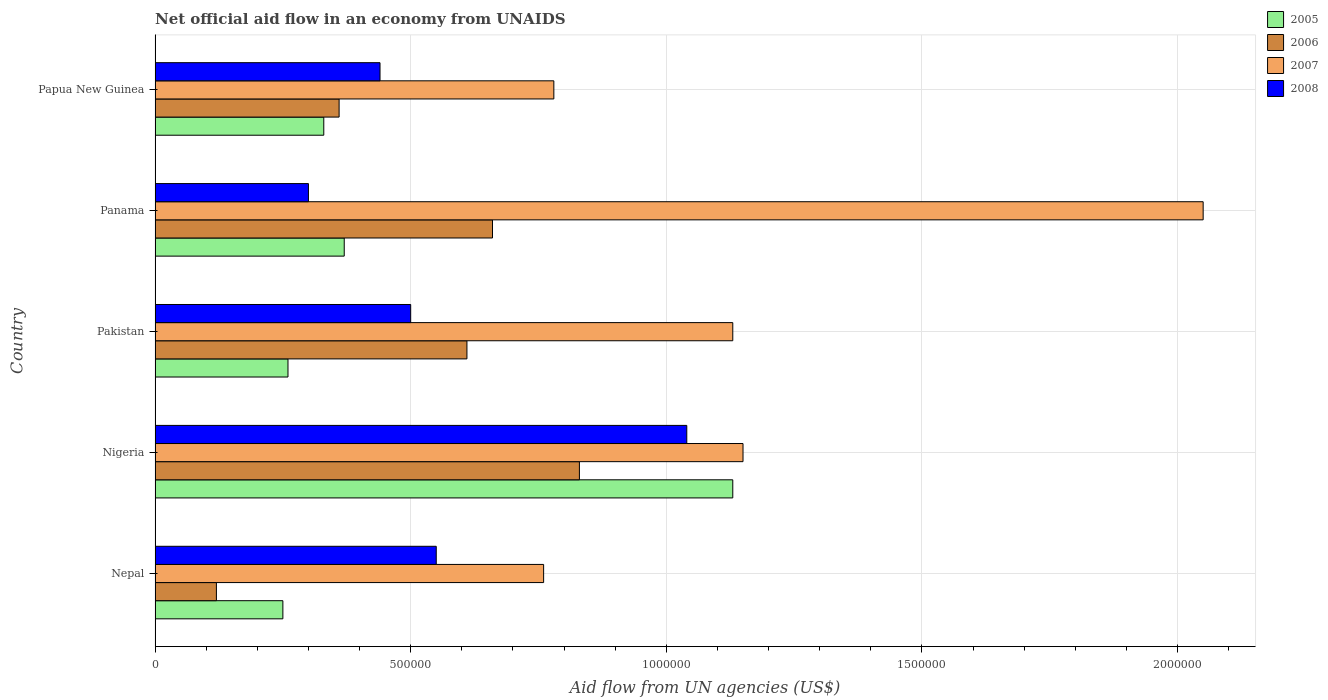How many groups of bars are there?
Offer a terse response. 5. Are the number of bars on each tick of the Y-axis equal?
Offer a very short reply. Yes. What is the label of the 5th group of bars from the top?
Make the answer very short. Nepal. Across all countries, what is the maximum net official aid flow in 2007?
Provide a succinct answer. 2.05e+06. Across all countries, what is the minimum net official aid flow in 2008?
Give a very brief answer. 3.00e+05. In which country was the net official aid flow in 2007 maximum?
Keep it short and to the point. Panama. In which country was the net official aid flow in 2006 minimum?
Keep it short and to the point. Nepal. What is the total net official aid flow in 2005 in the graph?
Your answer should be very brief. 2.34e+06. What is the difference between the net official aid flow in 2008 in Nigeria and that in Panama?
Ensure brevity in your answer.  7.40e+05. What is the difference between the net official aid flow in 2007 in Panama and the net official aid flow in 2005 in Pakistan?
Provide a succinct answer. 1.79e+06. What is the average net official aid flow in 2008 per country?
Your response must be concise. 5.66e+05. What is the difference between the net official aid flow in 2007 and net official aid flow in 2006 in Nepal?
Your answer should be compact. 6.40e+05. What is the ratio of the net official aid flow in 2006 in Nepal to that in Pakistan?
Provide a succinct answer. 0.2. Is the difference between the net official aid flow in 2007 in Panama and Papua New Guinea greater than the difference between the net official aid flow in 2006 in Panama and Papua New Guinea?
Offer a terse response. Yes. What is the difference between the highest and the second highest net official aid flow in 2005?
Your response must be concise. 7.60e+05. What is the difference between the highest and the lowest net official aid flow in 2005?
Provide a succinct answer. 8.80e+05. Is the sum of the net official aid flow in 2007 in Nigeria and Pakistan greater than the maximum net official aid flow in 2005 across all countries?
Give a very brief answer. Yes. Is it the case that in every country, the sum of the net official aid flow in 2006 and net official aid flow in 2005 is greater than the sum of net official aid flow in 2008 and net official aid flow in 2007?
Your answer should be very brief. No. What does the 3rd bar from the bottom in Papua New Guinea represents?
Ensure brevity in your answer.  2007. How many bars are there?
Give a very brief answer. 20. Are all the bars in the graph horizontal?
Offer a terse response. Yes. How many countries are there in the graph?
Provide a short and direct response. 5. Does the graph contain any zero values?
Give a very brief answer. No. Where does the legend appear in the graph?
Provide a succinct answer. Top right. How many legend labels are there?
Your answer should be compact. 4. What is the title of the graph?
Keep it short and to the point. Net official aid flow in an economy from UNAIDS. What is the label or title of the X-axis?
Your answer should be compact. Aid flow from UN agencies (US$). What is the label or title of the Y-axis?
Your answer should be compact. Country. What is the Aid flow from UN agencies (US$) of 2007 in Nepal?
Offer a terse response. 7.60e+05. What is the Aid flow from UN agencies (US$) of 2005 in Nigeria?
Offer a terse response. 1.13e+06. What is the Aid flow from UN agencies (US$) in 2006 in Nigeria?
Your answer should be compact. 8.30e+05. What is the Aid flow from UN agencies (US$) of 2007 in Nigeria?
Provide a succinct answer. 1.15e+06. What is the Aid flow from UN agencies (US$) in 2008 in Nigeria?
Give a very brief answer. 1.04e+06. What is the Aid flow from UN agencies (US$) of 2006 in Pakistan?
Provide a short and direct response. 6.10e+05. What is the Aid flow from UN agencies (US$) of 2007 in Pakistan?
Ensure brevity in your answer.  1.13e+06. What is the Aid flow from UN agencies (US$) of 2008 in Pakistan?
Offer a terse response. 5.00e+05. What is the Aid flow from UN agencies (US$) in 2005 in Panama?
Offer a very short reply. 3.70e+05. What is the Aid flow from UN agencies (US$) in 2007 in Panama?
Provide a short and direct response. 2.05e+06. What is the Aid flow from UN agencies (US$) of 2005 in Papua New Guinea?
Your response must be concise. 3.30e+05. What is the Aid flow from UN agencies (US$) in 2006 in Papua New Guinea?
Your response must be concise. 3.60e+05. What is the Aid flow from UN agencies (US$) of 2007 in Papua New Guinea?
Keep it short and to the point. 7.80e+05. Across all countries, what is the maximum Aid flow from UN agencies (US$) in 2005?
Ensure brevity in your answer.  1.13e+06. Across all countries, what is the maximum Aid flow from UN agencies (US$) of 2006?
Offer a terse response. 8.30e+05. Across all countries, what is the maximum Aid flow from UN agencies (US$) in 2007?
Your answer should be compact. 2.05e+06. Across all countries, what is the maximum Aid flow from UN agencies (US$) in 2008?
Make the answer very short. 1.04e+06. Across all countries, what is the minimum Aid flow from UN agencies (US$) of 2006?
Your answer should be compact. 1.20e+05. Across all countries, what is the minimum Aid flow from UN agencies (US$) in 2007?
Offer a terse response. 7.60e+05. What is the total Aid flow from UN agencies (US$) in 2005 in the graph?
Your answer should be very brief. 2.34e+06. What is the total Aid flow from UN agencies (US$) of 2006 in the graph?
Your answer should be compact. 2.58e+06. What is the total Aid flow from UN agencies (US$) in 2007 in the graph?
Provide a short and direct response. 5.87e+06. What is the total Aid flow from UN agencies (US$) in 2008 in the graph?
Offer a very short reply. 2.83e+06. What is the difference between the Aid flow from UN agencies (US$) in 2005 in Nepal and that in Nigeria?
Ensure brevity in your answer.  -8.80e+05. What is the difference between the Aid flow from UN agencies (US$) in 2006 in Nepal and that in Nigeria?
Offer a terse response. -7.10e+05. What is the difference between the Aid flow from UN agencies (US$) of 2007 in Nepal and that in Nigeria?
Offer a very short reply. -3.90e+05. What is the difference between the Aid flow from UN agencies (US$) of 2008 in Nepal and that in Nigeria?
Keep it short and to the point. -4.90e+05. What is the difference between the Aid flow from UN agencies (US$) of 2005 in Nepal and that in Pakistan?
Give a very brief answer. -10000. What is the difference between the Aid flow from UN agencies (US$) of 2006 in Nepal and that in Pakistan?
Provide a succinct answer. -4.90e+05. What is the difference between the Aid flow from UN agencies (US$) in 2007 in Nepal and that in Pakistan?
Provide a short and direct response. -3.70e+05. What is the difference between the Aid flow from UN agencies (US$) in 2008 in Nepal and that in Pakistan?
Ensure brevity in your answer.  5.00e+04. What is the difference between the Aid flow from UN agencies (US$) in 2006 in Nepal and that in Panama?
Provide a short and direct response. -5.40e+05. What is the difference between the Aid flow from UN agencies (US$) in 2007 in Nepal and that in Panama?
Keep it short and to the point. -1.29e+06. What is the difference between the Aid flow from UN agencies (US$) of 2008 in Nepal and that in Panama?
Provide a succinct answer. 2.50e+05. What is the difference between the Aid flow from UN agencies (US$) of 2005 in Nepal and that in Papua New Guinea?
Keep it short and to the point. -8.00e+04. What is the difference between the Aid flow from UN agencies (US$) in 2007 in Nepal and that in Papua New Guinea?
Your answer should be compact. -2.00e+04. What is the difference between the Aid flow from UN agencies (US$) of 2008 in Nepal and that in Papua New Guinea?
Ensure brevity in your answer.  1.10e+05. What is the difference between the Aid flow from UN agencies (US$) of 2005 in Nigeria and that in Pakistan?
Ensure brevity in your answer.  8.70e+05. What is the difference between the Aid flow from UN agencies (US$) of 2008 in Nigeria and that in Pakistan?
Provide a short and direct response. 5.40e+05. What is the difference between the Aid flow from UN agencies (US$) of 2005 in Nigeria and that in Panama?
Provide a short and direct response. 7.60e+05. What is the difference between the Aid flow from UN agencies (US$) in 2006 in Nigeria and that in Panama?
Offer a terse response. 1.70e+05. What is the difference between the Aid flow from UN agencies (US$) of 2007 in Nigeria and that in Panama?
Provide a succinct answer. -9.00e+05. What is the difference between the Aid flow from UN agencies (US$) in 2008 in Nigeria and that in Panama?
Keep it short and to the point. 7.40e+05. What is the difference between the Aid flow from UN agencies (US$) of 2005 in Nigeria and that in Papua New Guinea?
Your response must be concise. 8.00e+05. What is the difference between the Aid flow from UN agencies (US$) of 2007 in Nigeria and that in Papua New Guinea?
Make the answer very short. 3.70e+05. What is the difference between the Aid flow from UN agencies (US$) of 2008 in Nigeria and that in Papua New Guinea?
Your answer should be compact. 6.00e+05. What is the difference between the Aid flow from UN agencies (US$) of 2005 in Pakistan and that in Panama?
Provide a short and direct response. -1.10e+05. What is the difference between the Aid flow from UN agencies (US$) in 2007 in Pakistan and that in Panama?
Provide a succinct answer. -9.20e+05. What is the difference between the Aid flow from UN agencies (US$) of 2008 in Pakistan and that in Panama?
Your response must be concise. 2.00e+05. What is the difference between the Aid flow from UN agencies (US$) in 2006 in Pakistan and that in Papua New Guinea?
Ensure brevity in your answer.  2.50e+05. What is the difference between the Aid flow from UN agencies (US$) of 2007 in Panama and that in Papua New Guinea?
Provide a succinct answer. 1.27e+06. What is the difference between the Aid flow from UN agencies (US$) in 2008 in Panama and that in Papua New Guinea?
Your answer should be compact. -1.40e+05. What is the difference between the Aid flow from UN agencies (US$) of 2005 in Nepal and the Aid flow from UN agencies (US$) of 2006 in Nigeria?
Provide a short and direct response. -5.80e+05. What is the difference between the Aid flow from UN agencies (US$) of 2005 in Nepal and the Aid flow from UN agencies (US$) of 2007 in Nigeria?
Your answer should be very brief. -9.00e+05. What is the difference between the Aid flow from UN agencies (US$) of 2005 in Nepal and the Aid flow from UN agencies (US$) of 2008 in Nigeria?
Give a very brief answer. -7.90e+05. What is the difference between the Aid flow from UN agencies (US$) of 2006 in Nepal and the Aid flow from UN agencies (US$) of 2007 in Nigeria?
Ensure brevity in your answer.  -1.03e+06. What is the difference between the Aid flow from UN agencies (US$) of 2006 in Nepal and the Aid flow from UN agencies (US$) of 2008 in Nigeria?
Provide a short and direct response. -9.20e+05. What is the difference between the Aid flow from UN agencies (US$) in 2007 in Nepal and the Aid flow from UN agencies (US$) in 2008 in Nigeria?
Your response must be concise. -2.80e+05. What is the difference between the Aid flow from UN agencies (US$) in 2005 in Nepal and the Aid flow from UN agencies (US$) in 2006 in Pakistan?
Provide a succinct answer. -3.60e+05. What is the difference between the Aid flow from UN agencies (US$) of 2005 in Nepal and the Aid flow from UN agencies (US$) of 2007 in Pakistan?
Provide a short and direct response. -8.80e+05. What is the difference between the Aid flow from UN agencies (US$) of 2006 in Nepal and the Aid flow from UN agencies (US$) of 2007 in Pakistan?
Provide a succinct answer. -1.01e+06. What is the difference between the Aid flow from UN agencies (US$) of 2006 in Nepal and the Aid flow from UN agencies (US$) of 2008 in Pakistan?
Provide a succinct answer. -3.80e+05. What is the difference between the Aid flow from UN agencies (US$) in 2005 in Nepal and the Aid flow from UN agencies (US$) in 2006 in Panama?
Your answer should be very brief. -4.10e+05. What is the difference between the Aid flow from UN agencies (US$) of 2005 in Nepal and the Aid flow from UN agencies (US$) of 2007 in Panama?
Offer a terse response. -1.80e+06. What is the difference between the Aid flow from UN agencies (US$) of 2005 in Nepal and the Aid flow from UN agencies (US$) of 2008 in Panama?
Ensure brevity in your answer.  -5.00e+04. What is the difference between the Aid flow from UN agencies (US$) in 2006 in Nepal and the Aid flow from UN agencies (US$) in 2007 in Panama?
Provide a short and direct response. -1.93e+06. What is the difference between the Aid flow from UN agencies (US$) of 2006 in Nepal and the Aid flow from UN agencies (US$) of 2008 in Panama?
Keep it short and to the point. -1.80e+05. What is the difference between the Aid flow from UN agencies (US$) in 2007 in Nepal and the Aid flow from UN agencies (US$) in 2008 in Panama?
Make the answer very short. 4.60e+05. What is the difference between the Aid flow from UN agencies (US$) in 2005 in Nepal and the Aid flow from UN agencies (US$) in 2006 in Papua New Guinea?
Offer a very short reply. -1.10e+05. What is the difference between the Aid flow from UN agencies (US$) of 2005 in Nepal and the Aid flow from UN agencies (US$) of 2007 in Papua New Guinea?
Your answer should be very brief. -5.30e+05. What is the difference between the Aid flow from UN agencies (US$) in 2006 in Nepal and the Aid flow from UN agencies (US$) in 2007 in Papua New Guinea?
Ensure brevity in your answer.  -6.60e+05. What is the difference between the Aid flow from UN agencies (US$) of 2006 in Nepal and the Aid flow from UN agencies (US$) of 2008 in Papua New Guinea?
Provide a succinct answer. -3.20e+05. What is the difference between the Aid flow from UN agencies (US$) in 2005 in Nigeria and the Aid flow from UN agencies (US$) in 2006 in Pakistan?
Make the answer very short. 5.20e+05. What is the difference between the Aid flow from UN agencies (US$) of 2005 in Nigeria and the Aid flow from UN agencies (US$) of 2008 in Pakistan?
Provide a short and direct response. 6.30e+05. What is the difference between the Aid flow from UN agencies (US$) of 2006 in Nigeria and the Aid flow from UN agencies (US$) of 2007 in Pakistan?
Your answer should be very brief. -3.00e+05. What is the difference between the Aid flow from UN agencies (US$) in 2006 in Nigeria and the Aid flow from UN agencies (US$) in 2008 in Pakistan?
Provide a succinct answer. 3.30e+05. What is the difference between the Aid flow from UN agencies (US$) of 2007 in Nigeria and the Aid flow from UN agencies (US$) of 2008 in Pakistan?
Your response must be concise. 6.50e+05. What is the difference between the Aid flow from UN agencies (US$) in 2005 in Nigeria and the Aid flow from UN agencies (US$) in 2006 in Panama?
Give a very brief answer. 4.70e+05. What is the difference between the Aid flow from UN agencies (US$) of 2005 in Nigeria and the Aid flow from UN agencies (US$) of 2007 in Panama?
Ensure brevity in your answer.  -9.20e+05. What is the difference between the Aid flow from UN agencies (US$) of 2005 in Nigeria and the Aid flow from UN agencies (US$) of 2008 in Panama?
Ensure brevity in your answer.  8.30e+05. What is the difference between the Aid flow from UN agencies (US$) in 2006 in Nigeria and the Aid flow from UN agencies (US$) in 2007 in Panama?
Provide a succinct answer. -1.22e+06. What is the difference between the Aid flow from UN agencies (US$) in 2006 in Nigeria and the Aid flow from UN agencies (US$) in 2008 in Panama?
Your answer should be very brief. 5.30e+05. What is the difference between the Aid flow from UN agencies (US$) in 2007 in Nigeria and the Aid flow from UN agencies (US$) in 2008 in Panama?
Offer a terse response. 8.50e+05. What is the difference between the Aid flow from UN agencies (US$) in 2005 in Nigeria and the Aid flow from UN agencies (US$) in 2006 in Papua New Guinea?
Make the answer very short. 7.70e+05. What is the difference between the Aid flow from UN agencies (US$) of 2005 in Nigeria and the Aid flow from UN agencies (US$) of 2007 in Papua New Guinea?
Make the answer very short. 3.50e+05. What is the difference between the Aid flow from UN agencies (US$) of 2005 in Nigeria and the Aid flow from UN agencies (US$) of 2008 in Papua New Guinea?
Keep it short and to the point. 6.90e+05. What is the difference between the Aid flow from UN agencies (US$) in 2006 in Nigeria and the Aid flow from UN agencies (US$) in 2007 in Papua New Guinea?
Provide a short and direct response. 5.00e+04. What is the difference between the Aid flow from UN agencies (US$) in 2007 in Nigeria and the Aid flow from UN agencies (US$) in 2008 in Papua New Guinea?
Your answer should be compact. 7.10e+05. What is the difference between the Aid flow from UN agencies (US$) in 2005 in Pakistan and the Aid flow from UN agencies (US$) in 2006 in Panama?
Provide a short and direct response. -4.00e+05. What is the difference between the Aid flow from UN agencies (US$) in 2005 in Pakistan and the Aid flow from UN agencies (US$) in 2007 in Panama?
Keep it short and to the point. -1.79e+06. What is the difference between the Aid flow from UN agencies (US$) in 2006 in Pakistan and the Aid flow from UN agencies (US$) in 2007 in Panama?
Keep it short and to the point. -1.44e+06. What is the difference between the Aid flow from UN agencies (US$) in 2006 in Pakistan and the Aid flow from UN agencies (US$) in 2008 in Panama?
Your response must be concise. 3.10e+05. What is the difference between the Aid flow from UN agencies (US$) in 2007 in Pakistan and the Aid flow from UN agencies (US$) in 2008 in Panama?
Your response must be concise. 8.30e+05. What is the difference between the Aid flow from UN agencies (US$) in 2005 in Pakistan and the Aid flow from UN agencies (US$) in 2007 in Papua New Guinea?
Offer a terse response. -5.20e+05. What is the difference between the Aid flow from UN agencies (US$) in 2005 in Pakistan and the Aid flow from UN agencies (US$) in 2008 in Papua New Guinea?
Keep it short and to the point. -1.80e+05. What is the difference between the Aid flow from UN agencies (US$) in 2006 in Pakistan and the Aid flow from UN agencies (US$) in 2007 in Papua New Guinea?
Ensure brevity in your answer.  -1.70e+05. What is the difference between the Aid flow from UN agencies (US$) in 2006 in Pakistan and the Aid flow from UN agencies (US$) in 2008 in Papua New Guinea?
Your answer should be compact. 1.70e+05. What is the difference between the Aid flow from UN agencies (US$) of 2007 in Pakistan and the Aid flow from UN agencies (US$) of 2008 in Papua New Guinea?
Offer a very short reply. 6.90e+05. What is the difference between the Aid flow from UN agencies (US$) in 2005 in Panama and the Aid flow from UN agencies (US$) in 2007 in Papua New Guinea?
Your answer should be very brief. -4.10e+05. What is the difference between the Aid flow from UN agencies (US$) of 2006 in Panama and the Aid flow from UN agencies (US$) of 2007 in Papua New Guinea?
Keep it short and to the point. -1.20e+05. What is the difference between the Aid flow from UN agencies (US$) in 2007 in Panama and the Aid flow from UN agencies (US$) in 2008 in Papua New Guinea?
Give a very brief answer. 1.61e+06. What is the average Aid flow from UN agencies (US$) of 2005 per country?
Ensure brevity in your answer.  4.68e+05. What is the average Aid flow from UN agencies (US$) in 2006 per country?
Offer a very short reply. 5.16e+05. What is the average Aid flow from UN agencies (US$) of 2007 per country?
Ensure brevity in your answer.  1.17e+06. What is the average Aid flow from UN agencies (US$) of 2008 per country?
Provide a short and direct response. 5.66e+05. What is the difference between the Aid flow from UN agencies (US$) of 2005 and Aid flow from UN agencies (US$) of 2007 in Nepal?
Keep it short and to the point. -5.10e+05. What is the difference between the Aid flow from UN agencies (US$) in 2006 and Aid flow from UN agencies (US$) in 2007 in Nepal?
Keep it short and to the point. -6.40e+05. What is the difference between the Aid flow from UN agencies (US$) in 2006 and Aid flow from UN agencies (US$) in 2008 in Nepal?
Your response must be concise. -4.30e+05. What is the difference between the Aid flow from UN agencies (US$) in 2005 and Aid flow from UN agencies (US$) in 2007 in Nigeria?
Provide a short and direct response. -2.00e+04. What is the difference between the Aid flow from UN agencies (US$) of 2006 and Aid flow from UN agencies (US$) of 2007 in Nigeria?
Provide a succinct answer. -3.20e+05. What is the difference between the Aid flow from UN agencies (US$) in 2006 and Aid flow from UN agencies (US$) in 2008 in Nigeria?
Your answer should be very brief. -2.10e+05. What is the difference between the Aid flow from UN agencies (US$) of 2007 and Aid flow from UN agencies (US$) of 2008 in Nigeria?
Your answer should be compact. 1.10e+05. What is the difference between the Aid flow from UN agencies (US$) in 2005 and Aid flow from UN agencies (US$) in 2006 in Pakistan?
Keep it short and to the point. -3.50e+05. What is the difference between the Aid flow from UN agencies (US$) in 2005 and Aid flow from UN agencies (US$) in 2007 in Pakistan?
Your answer should be very brief. -8.70e+05. What is the difference between the Aid flow from UN agencies (US$) of 2005 and Aid flow from UN agencies (US$) of 2008 in Pakistan?
Make the answer very short. -2.40e+05. What is the difference between the Aid flow from UN agencies (US$) of 2006 and Aid flow from UN agencies (US$) of 2007 in Pakistan?
Provide a succinct answer. -5.20e+05. What is the difference between the Aid flow from UN agencies (US$) of 2006 and Aid flow from UN agencies (US$) of 2008 in Pakistan?
Offer a very short reply. 1.10e+05. What is the difference between the Aid flow from UN agencies (US$) of 2007 and Aid flow from UN agencies (US$) of 2008 in Pakistan?
Provide a succinct answer. 6.30e+05. What is the difference between the Aid flow from UN agencies (US$) of 2005 and Aid flow from UN agencies (US$) of 2006 in Panama?
Offer a terse response. -2.90e+05. What is the difference between the Aid flow from UN agencies (US$) in 2005 and Aid flow from UN agencies (US$) in 2007 in Panama?
Provide a short and direct response. -1.68e+06. What is the difference between the Aid flow from UN agencies (US$) of 2005 and Aid flow from UN agencies (US$) of 2008 in Panama?
Offer a terse response. 7.00e+04. What is the difference between the Aid flow from UN agencies (US$) of 2006 and Aid flow from UN agencies (US$) of 2007 in Panama?
Offer a terse response. -1.39e+06. What is the difference between the Aid flow from UN agencies (US$) of 2006 and Aid flow from UN agencies (US$) of 2008 in Panama?
Ensure brevity in your answer.  3.60e+05. What is the difference between the Aid flow from UN agencies (US$) in 2007 and Aid flow from UN agencies (US$) in 2008 in Panama?
Give a very brief answer. 1.75e+06. What is the difference between the Aid flow from UN agencies (US$) in 2005 and Aid flow from UN agencies (US$) in 2007 in Papua New Guinea?
Your answer should be very brief. -4.50e+05. What is the difference between the Aid flow from UN agencies (US$) of 2005 and Aid flow from UN agencies (US$) of 2008 in Papua New Guinea?
Offer a very short reply. -1.10e+05. What is the difference between the Aid flow from UN agencies (US$) of 2006 and Aid flow from UN agencies (US$) of 2007 in Papua New Guinea?
Keep it short and to the point. -4.20e+05. What is the difference between the Aid flow from UN agencies (US$) of 2006 and Aid flow from UN agencies (US$) of 2008 in Papua New Guinea?
Offer a very short reply. -8.00e+04. What is the ratio of the Aid flow from UN agencies (US$) of 2005 in Nepal to that in Nigeria?
Your response must be concise. 0.22. What is the ratio of the Aid flow from UN agencies (US$) in 2006 in Nepal to that in Nigeria?
Your answer should be compact. 0.14. What is the ratio of the Aid flow from UN agencies (US$) in 2007 in Nepal to that in Nigeria?
Give a very brief answer. 0.66. What is the ratio of the Aid flow from UN agencies (US$) of 2008 in Nepal to that in Nigeria?
Keep it short and to the point. 0.53. What is the ratio of the Aid flow from UN agencies (US$) of 2005 in Nepal to that in Pakistan?
Your answer should be very brief. 0.96. What is the ratio of the Aid flow from UN agencies (US$) of 2006 in Nepal to that in Pakistan?
Keep it short and to the point. 0.2. What is the ratio of the Aid flow from UN agencies (US$) of 2007 in Nepal to that in Pakistan?
Make the answer very short. 0.67. What is the ratio of the Aid flow from UN agencies (US$) of 2005 in Nepal to that in Panama?
Ensure brevity in your answer.  0.68. What is the ratio of the Aid flow from UN agencies (US$) of 2006 in Nepal to that in Panama?
Provide a short and direct response. 0.18. What is the ratio of the Aid flow from UN agencies (US$) of 2007 in Nepal to that in Panama?
Offer a terse response. 0.37. What is the ratio of the Aid flow from UN agencies (US$) in 2008 in Nepal to that in Panama?
Provide a succinct answer. 1.83. What is the ratio of the Aid flow from UN agencies (US$) of 2005 in Nepal to that in Papua New Guinea?
Offer a very short reply. 0.76. What is the ratio of the Aid flow from UN agencies (US$) in 2006 in Nepal to that in Papua New Guinea?
Keep it short and to the point. 0.33. What is the ratio of the Aid flow from UN agencies (US$) in 2007 in Nepal to that in Papua New Guinea?
Your response must be concise. 0.97. What is the ratio of the Aid flow from UN agencies (US$) of 2005 in Nigeria to that in Pakistan?
Provide a succinct answer. 4.35. What is the ratio of the Aid flow from UN agencies (US$) in 2006 in Nigeria to that in Pakistan?
Provide a short and direct response. 1.36. What is the ratio of the Aid flow from UN agencies (US$) in 2007 in Nigeria to that in Pakistan?
Offer a very short reply. 1.02. What is the ratio of the Aid flow from UN agencies (US$) of 2008 in Nigeria to that in Pakistan?
Provide a short and direct response. 2.08. What is the ratio of the Aid flow from UN agencies (US$) in 2005 in Nigeria to that in Panama?
Keep it short and to the point. 3.05. What is the ratio of the Aid flow from UN agencies (US$) of 2006 in Nigeria to that in Panama?
Your answer should be very brief. 1.26. What is the ratio of the Aid flow from UN agencies (US$) in 2007 in Nigeria to that in Panama?
Your response must be concise. 0.56. What is the ratio of the Aid flow from UN agencies (US$) of 2008 in Nigeria to that in Panama?
Your response must be concise. 3.47. What is the ratio of the Aid flow from UN agencies (US$) in 2005 in Nigeria to that in Papua New Guinea?
Ensure brevity in your answer.  3.42. What is the ratio of the Aid flow from UN agencies (US$) of 2006 in Nigeria to that in Papua New Guinea?
Provide a succinct answer. 2.31. What is the ratio of the Aid flow from UN agencies (US$) of 2007 in Nigeria to that in Papua New Guinea?
Your answer should be compact. 1.47. What is the ratio of the Aid flow from UN agencies (US$) of 2008 in Nigeria to that in Papua New Guinea?
Make the answer very short. 2.36. What is the ratio of the Aid flow from UN agencies (US$) in 2005 in Pakistan to that in Panama?
Your response must be concise. 0.7. What is the ratio of the Aid flow from UN agencies (US$) in 2006 in Pakistan to that in Panama?
Give a very brief answer. 0.92. What is the ratio of the Aid flow from UN agencies (US$) in 2007 in Pakistan to that in Panama?
Your answer should be compact. 0.55. What is the ratio of the Aid flow from UN agencies (US$) in 2005 in Pakistan to that in Papua New Guinea?
Provide a short and direct response. 0.79. What is the ratio of the Aid flow from UN agencies (US$) in 2006 in Pakistan to that in Papua New Guinea?
Ensure brevity in your answer.  1.69. What is the ratio of the Aid flow from UN agencies (US$) of 2007 in Pakistan to that in Papua New Guinea?
Ensure brevity in your answer.  1.45. What is the ratio of the Aid flow from UN agencies (US$) in 2008 in Pakistan to that in Papua New Guinea?
Ensure brevity in your answer.  1.14. What is the ratio of the Aid flow from UN agencies (US$) of 2005 in Panama to that in Papua New Guinea?
Your response must be concise. 1.12. What is the ratio of the Aid flow from UN agencies (US$) of 2006 in Panama to that in Papua New Guinea?
Keep it short and to the point. 1.83. What is the ratio of the Aid flow from UN agencies (US$) in 2007 in Panama to that in Papua New Guinea?
Your answer should be very brief. 2.63. What is the ratio of the Aid flow from UN agencies (US$) in 2008 in Panama to that in Papua New Guinea?
Your response must be concise. 0.68. What is the difference between the highest and the second highest Aid flow from UN agencies (US$) in 2005?
Keep it short and to the point. 7.60e+05. What is the difference between the highest and the second highest Aid flow from UN agencies (US$) in 2006?
Provide a succinct answer. 1.70e+05. What is the difference between the highest and the lowest Aid flow from UN agencies (US$) in 2005?
Give a very brief answer. 8.80e+05. What is the difference between the highest and the lowest Aid flow from UN agencies (US$) in 2006?
Your answer should be compact. 7.10e+05. What is the difference between the highest and the lowest Aid flow from UN agencies (US$) of 2007?
Offer a terse response. 1.29e+06. What is the difference between the highest and the lowest Aid flow from UN agencies (US$) of 2008?
Make the answer very short. 7.40e+05. 